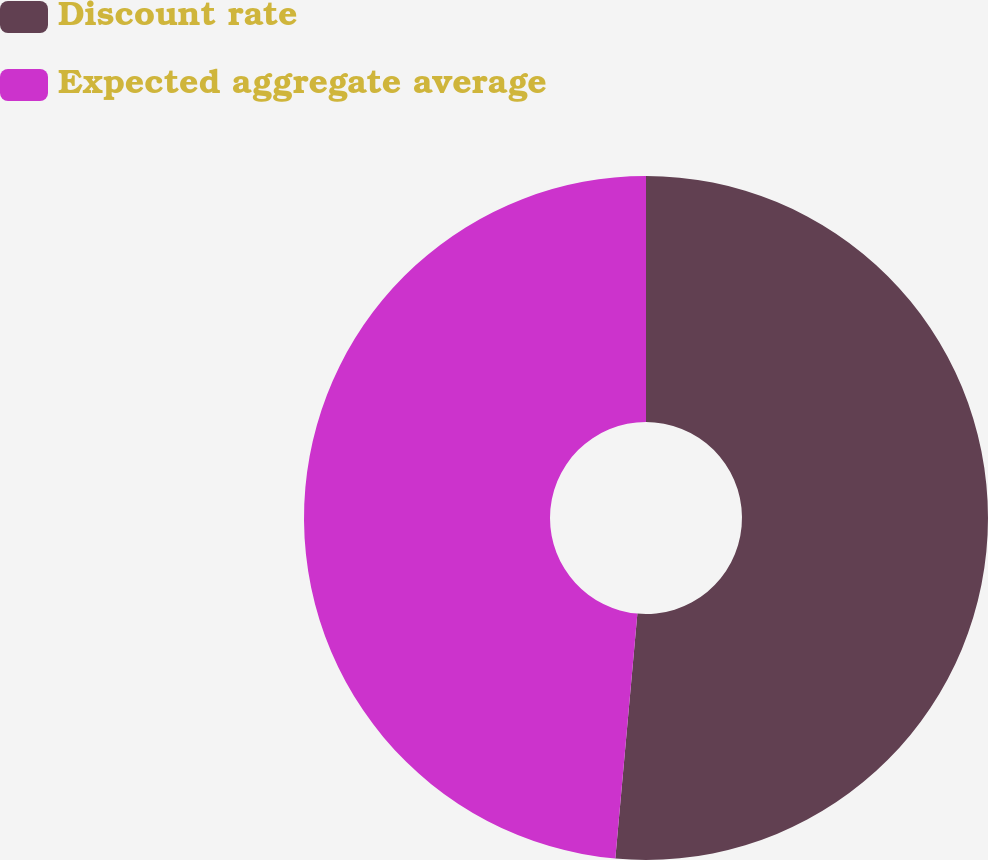Convert chart to OTSL. <chart><loc_0><loc_0><loc_500><loc_500><pie_chart><fcel>Discount rate<fcel>Expected aggregate average<nl><fcel>51.43%<fcel>48.57%<nl></chart> 